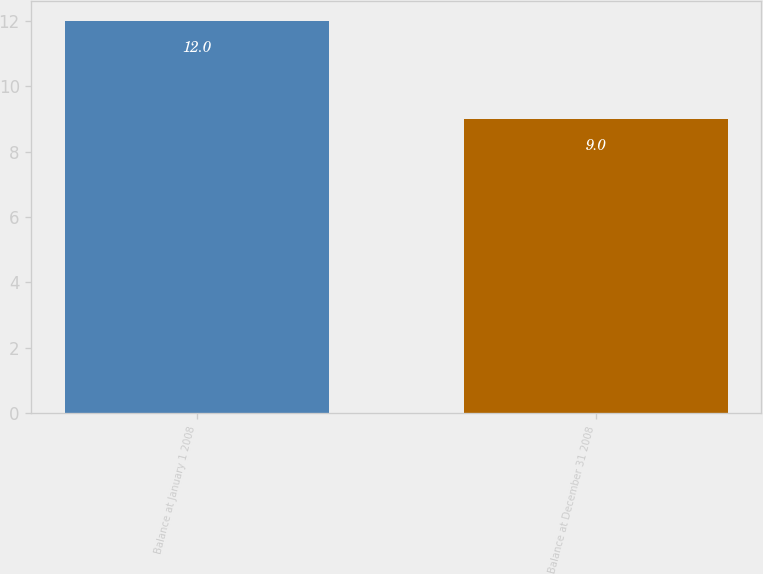<chart> <loc_0><loc_0><loc_500><loc_500><bar_chart><fcel>Balance at January 1 2008<fcel>Balance at December 31 2008<nl><fcel>12<fcel>9<nl></chart> 